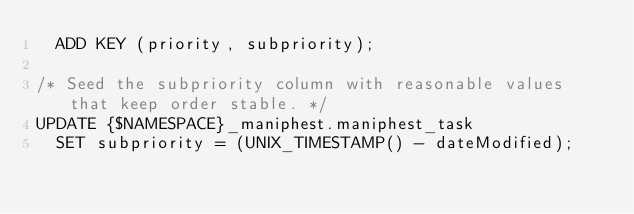<code> <loc_0><loc_0><loc_500><loc_500><_SQL_>  ADD KEY (priority, subpriority);

/* Seed the subpriority column with reasonable values that keep order stable. */
UPDATE {$NAMESPACE}_maniphest.maniphest_task
  SET subpriority = (UNIX_TIMESTAMP() - dateModified);


</code> 